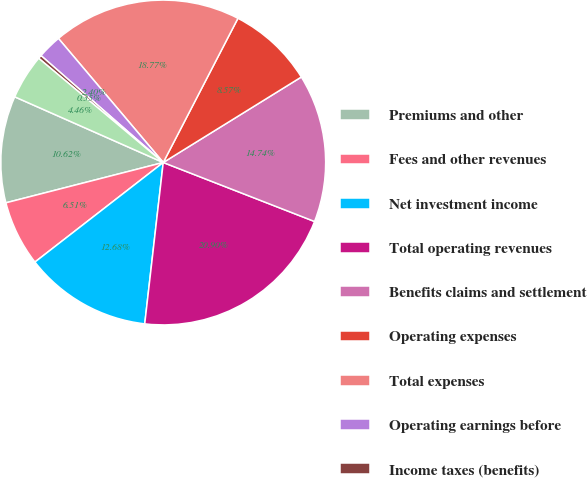<chart> <loc_0><loc_0><loc_500><loc_500><pie_chart><fcel>Premiums and other<fcel>Fees and other revenues<fcel>Net investment income<fcel>Total operating revenues<fcel>Benefits claims and settlement<fcel>Operating expenses<fcel>Total expenses<fcel>Operating earnings before<fcel>Income taxes (benefits)<fcel>Operating earnings<nl><fcel>10.62%<fcel>6.51%<fcel>12.68%<fcel>20.9%<fcel>14.74%<fcel>8.57%<fcel>18.77%<fcel>2.4%<fcel>0.35%<fcel>4.46%<nl></chart> 